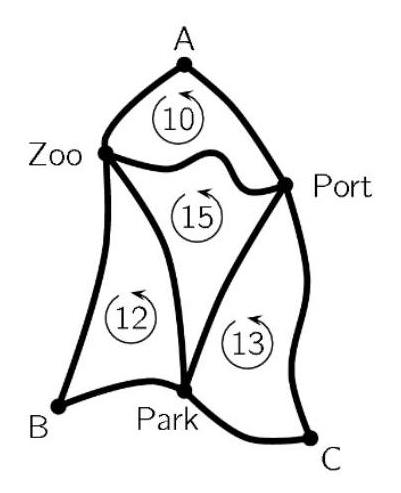How can understanding this diagram help in real-world applications such as urban planning? This diagram is a valuable educational tool for urban planning as it can help planners understand the importance of layout and connectivity in transportation networks. Properly assessing the shortest routes between key locations not only reduces travel time but also can significantly cut down on fuel consumption and traffic congestion. The principles demonstrated here are directly applicable in the planning of services like public transport routes, emergency services paths, and overall city connectivity. 